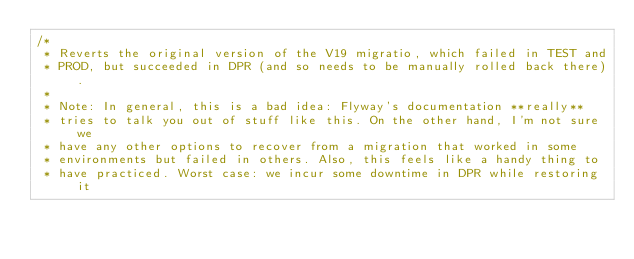Convert code to text. <code><loc_0><loc_0><loc_500><loc_500><_SQL_>/*
 * Reverts the original version of the V19 migratio, which failed in TEST and
 * PROD, but succeeded in DPR (and so needs to be manually rolled back there).
 * 
 * Note: In general, this is a bad idea: Flyway's documentation **really**
 * tries to talk you out of stuff like this. On the other hand, I'm not sure we
 * have any other options to recover from a migration that worked in some
 * environments but failed in others. Also, this feels like a handy thing to
 * have practiced. Worst case: we incur some downtime in DPR while restoring it</code> 